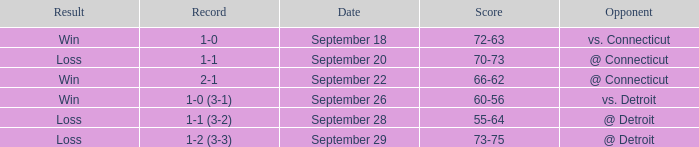WHAT IS THE SCORE WITH A RECORD OF 1-0? 72-63. 